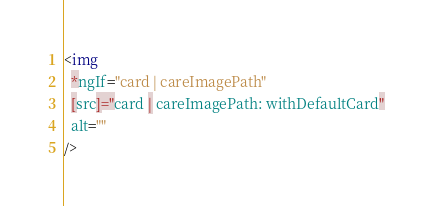<code> <loc_0><loc_0><loc_500><loc_500><_HTML_><img
  *ngIf="card | careImagePath"
  [src]="card | careImagePath: withDefaultCard"
  alt=""
/>
</code> 